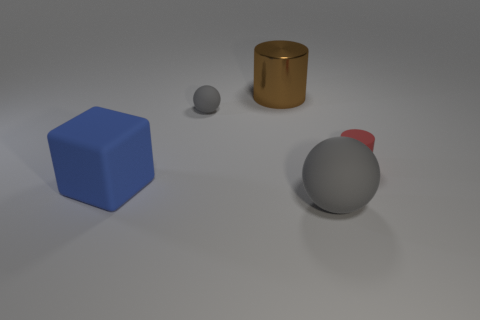What is the material of the gray sphere that is in front of the ball that is behind the large gray rubber object?
Make the answer very short. Rubber. How many things are right of the small gray object and in front of the red cylinder?
Your answer should be compact. 1. How many other objects are there of the same size as the brown shiny object?
Offer a terse response. 2. There is a tiny thing that is on the right side of the big shiny thing; is its shape the same as the object that is in front of the big matte block?
Give a very brief answer. No. Are there any large matte objects left of the large rubber sphere?
Offer a very short reply. Yes. The other tiny thing that is the same shape as the brown thing is what color?
Provide a short and direct response. Red. Is there anything else that has the same shape as the tiny red matte object?
Provide a succinct answer. Yes. What material is the small object that is to the right of the big gray thing?
Your answer should be very brief. Rubber. The metallic thing that is the same shape as the small red rubber thing is what size?
Provide a succinct answer. Large. What number of small gray spheres have the same material as the brown cylinder?
Offer a very short reply. 0. 